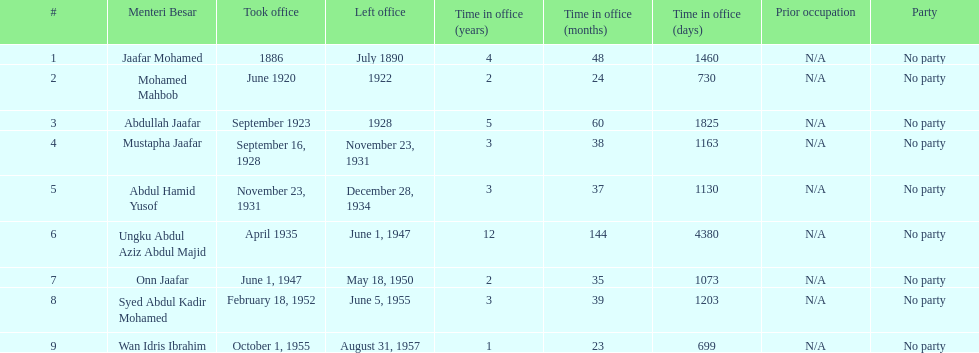Name someone who was not in office more than 4 years. Mohamed Mahbob. 